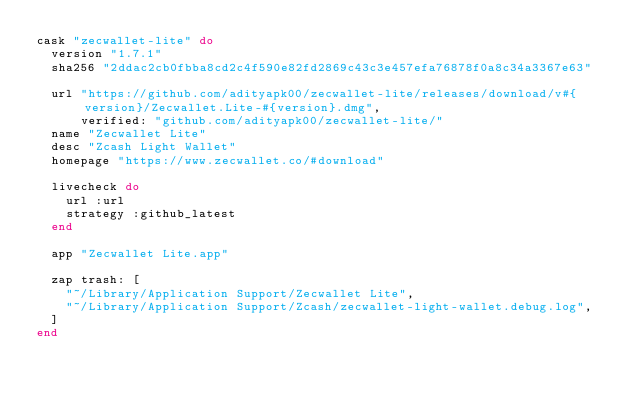<code> <loc_0><loc_0><loc_500><loc_500><_Ruby_>cask "zecwallet-lite" do
  version "1.7.1"
  sha256 "2ddac2cb0fbba8cd2c4f590e82fd2869c43c3e457efa76878f0a8c34a3367e63"

  url "https://github.com/adityapk00/zecwallet-lite/releases/download/v#{version}/Zecwallet.Lite-#{version}.dmg",
      verified: "github.com/adityapk00/zecwallet-lite/"
  name "Zecwallet Lite"
  desc "Zcash Light Wallet"
  homepage "https://www.zecwallet.co/#download"

  livecheck do
    url :url
    strategy :github_latest
  end

  app "Zecwallet Lite.app"

  zap trash: [
    "~/Library/Application Support/Zecwallet Lite",
    "~/Library/Application Support/Zcash/zecwallet-light-wallet.debug.log",
  ]
end
</code> 